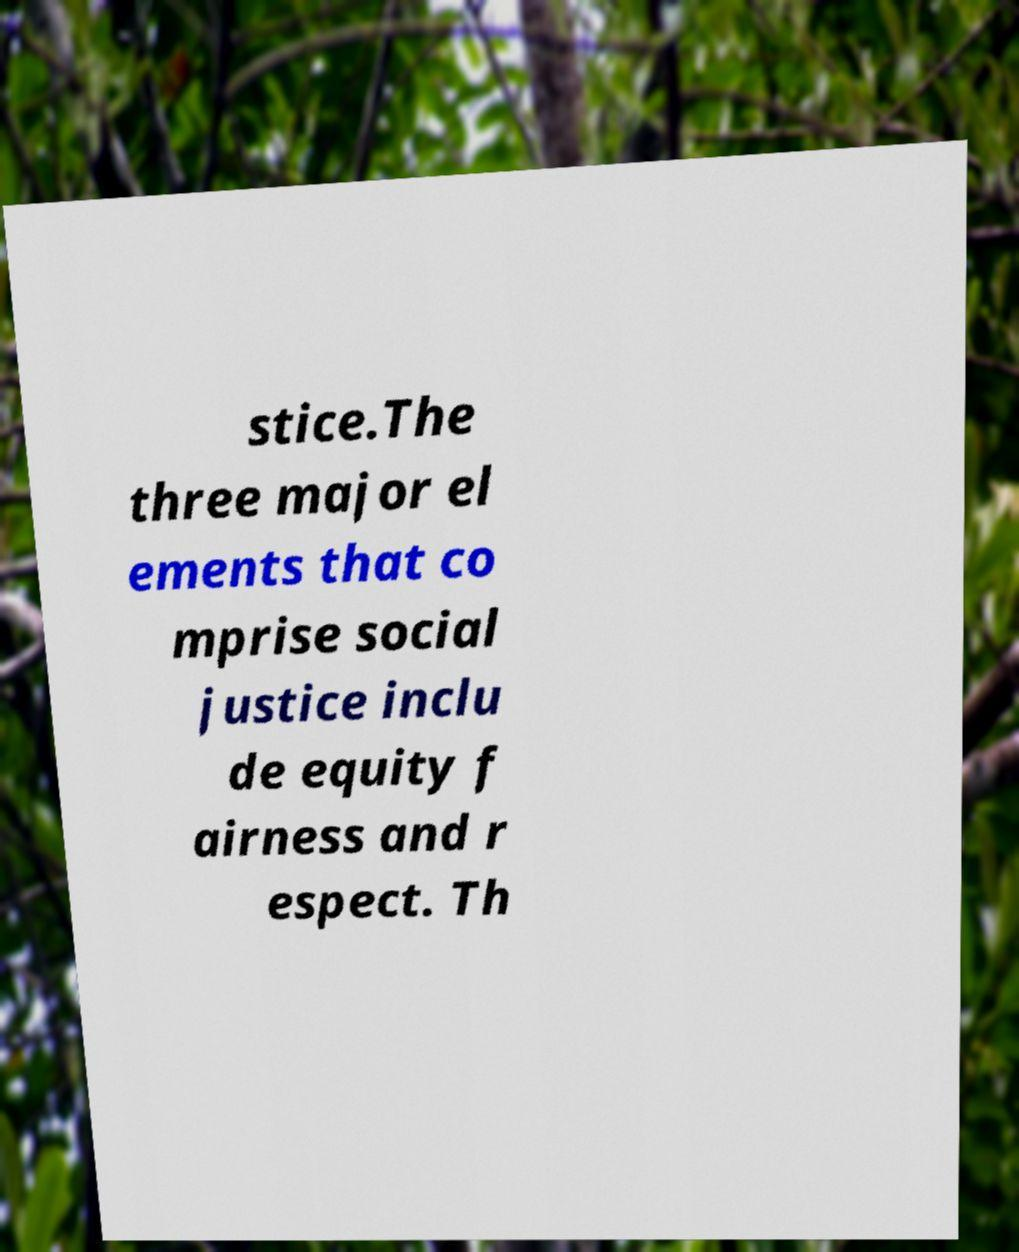Please identify and transcribe the text found in this image. stice.The three major el ements that co mprise social justice inclu de equity f airness and r espect. Th 